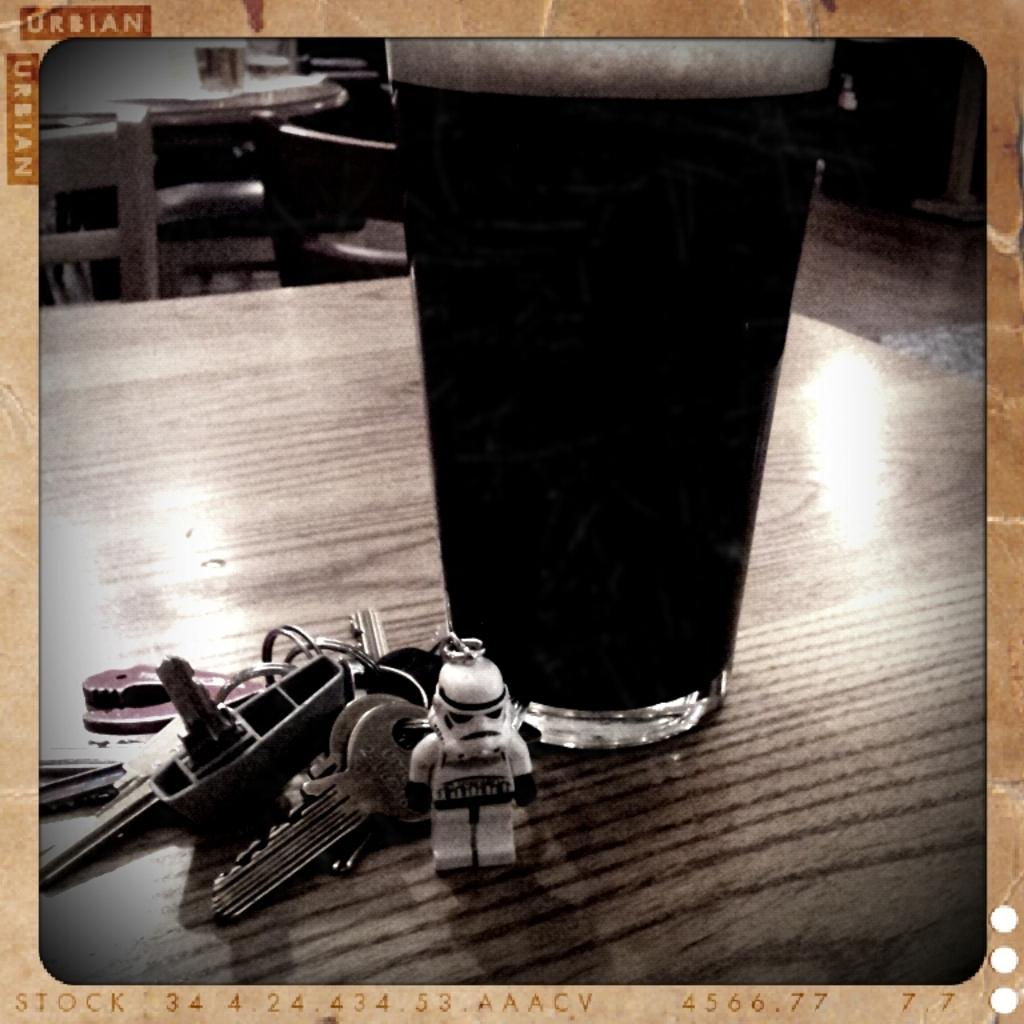What is on the table in the image? There is a glass on the table in the image. What else can be seen beside the glass on the table? There is a bunch of keys beside the glass on the table. How many trees are visible in the image? There are no trees visible in the image; it only shows a glass and a bunch of keys on a table. 